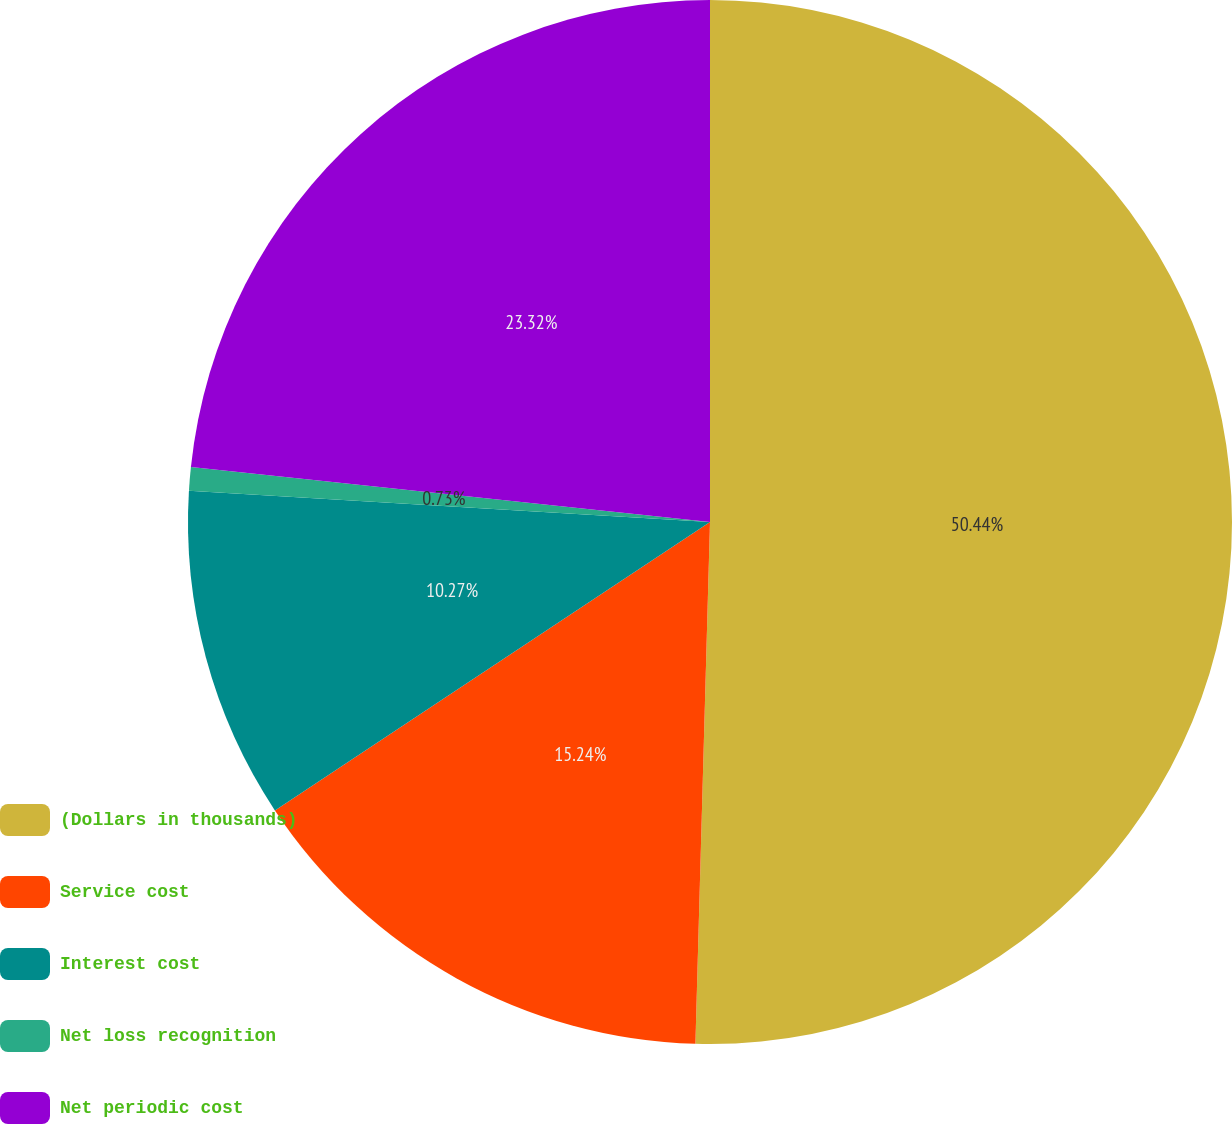<chart> <loc_0><loc_0><loc_500><loc_500><pie_chart><fcel>(Dollars in thousands)<fcel>Service cost<fcel>Interest cost<fcel>Net loss recognition<fcel>Net periodic cost<nl><fcel>50.45%<fcel>15.24%<fcel>10.27%<fcel>0.73%<fcel>23.32%<nl></chart> 